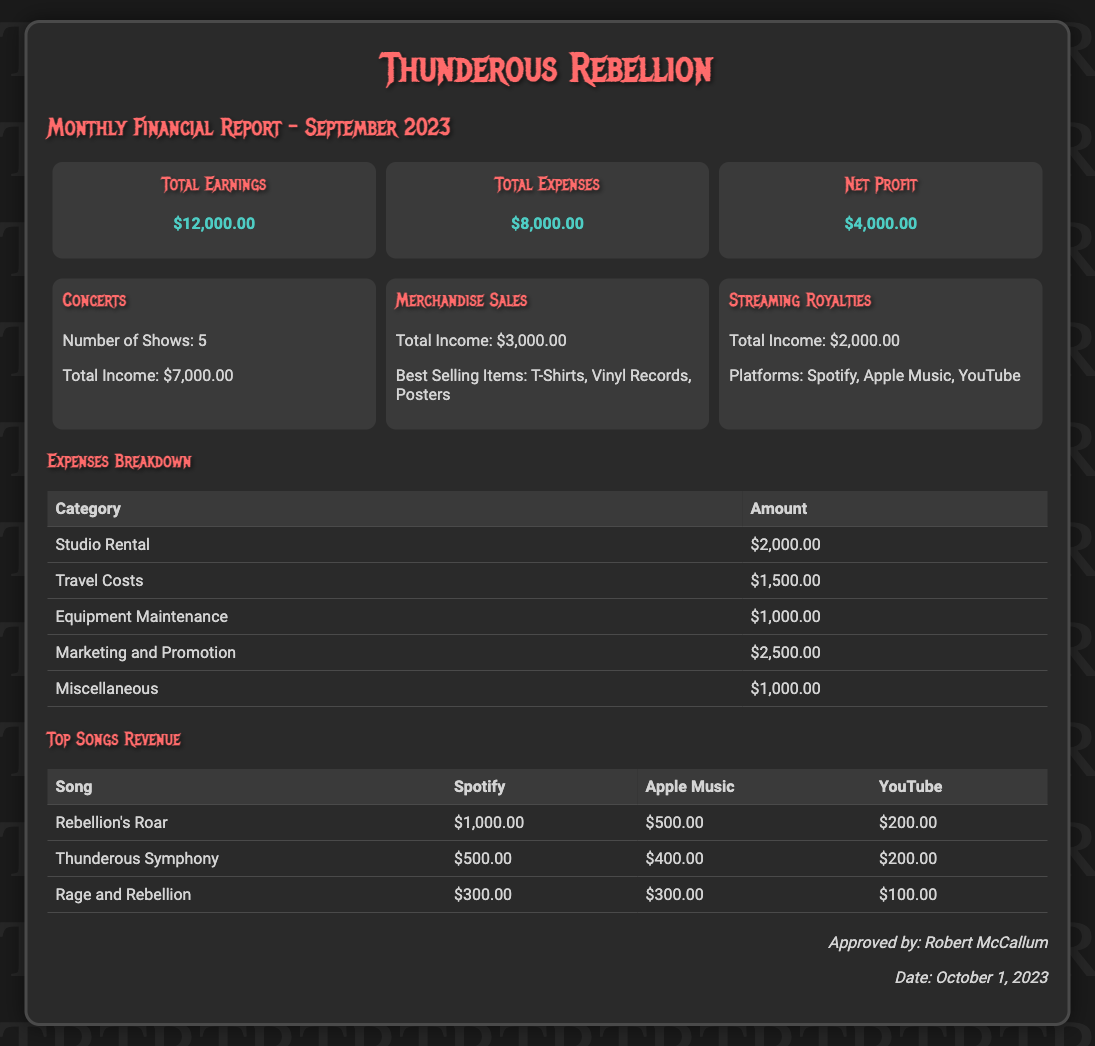What is the total earnings for September 2023? The total earnings for September 2023 is mentioned in the financial summary of the document.
Answer: $12,000.00 What is the total expenses incurred? The total expenses can be found in the financial summary, where it is explicitly stated.
Answer: $8,000.00 What is the net profit for the band? The net profit is calculated from the financial summary, shown by subtracting total expenses from total earnings.
Answer: $4,000.00 How many concerts were held this month? The number of shows conducted is provided under the revenue streams section specifically for concerts.
Answer: 5 What were the best selling merchandise items? The document lists the best selling merchandise items under the merchandise sales revenue stream.
Answer: T-Shirts, Vinyl Records, Posters What is the highest expense category? The highest expense can be determined from the expenses table by comparing the amounts of each category.
Answer: Marketing and Promotion Who approved the financial report? The approval of the financial report is mentioned at the end of the document, along with the approver's name.
Answer: Robert McCallum What is the date of report approval? The date of approval is listed in the approval section of the document.
Answer: October 1, 2023 Which song generated the most revenue on Spotify? The song with the highest revenue can be found by looking at the top songs revenue table for Spotify earnings.
Answer: Rebellion's Roar 